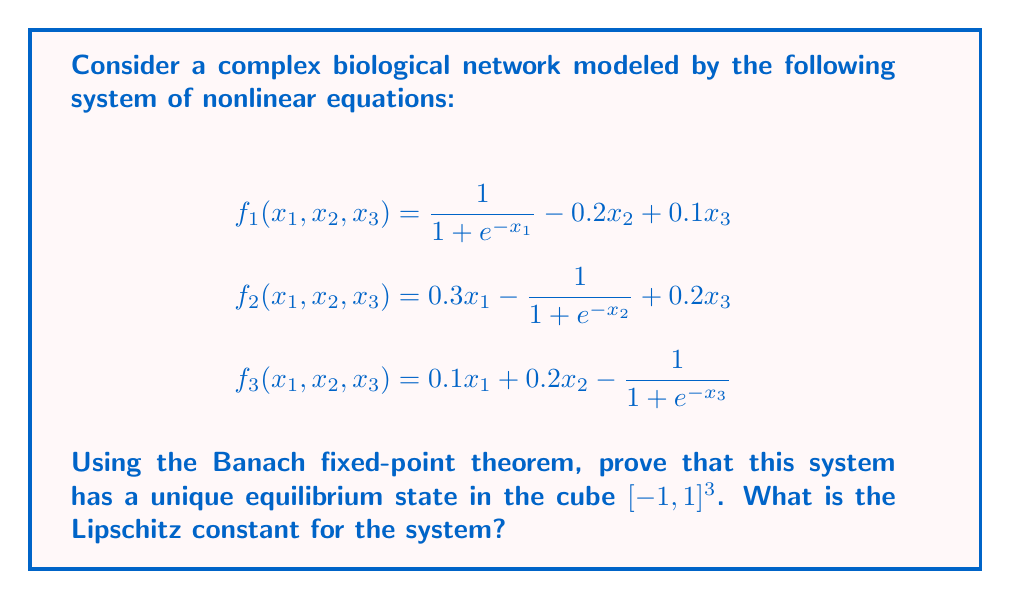Can you solve this math problem? To apply the Banach fixed-point theorem, we need to show that the function $F(x) = (f_1(x), f_2(x), f_3(x))$ is a contraction mapping on $[-1, 1]^3$.

Step 1: Show that $F$ maps $[-1, 1]^3$ to itself.
For each $f_i$, the sigmoid term $\frac{1}{1 + e^{-x_i}}$ is always in $[0, 1]$. The linear terms are bounded by $\pm 0.3$. Thus, $|f_i(x)| \leq 1$ for all $x \in [-1, 1]^3$.

Step 2: Compute the Jacobian matrix of $F$.
$$J = \begin{bmatrix}
\frac{e^{-x_1}}{(1 + e^{-x_1})^2} & -0.2 & 0.1 \\
0.3 & \frac{e^{-x_2}}{(1 + e^{-x_2})^2} & 0.2 \\
0.1 & 0.2 & \frac{e^{-x_3}}{(1 + e^{-x_3})^2}
\end{bmatrix}$$

Step 3: Find an upper bound for $\|J\|_\infty$.
The maximum value of $\frac{e^{-x}}{(1 + e^{-x})^2}$ is 0.25 (at $x = 0$).
$\|J\|_\infty = \max\{0.25 + 0.2 + 0.1, 0.3 + 0.25 + 0.2, 0.1 + 0.2 + 0.25\} = 0.75$

Step 4: Apply the mean value theorem.
For any $x, y \in [-1, 1]^3$, $\|F(x) - F(y)\|_\infty \leq 0.75\|x - y\|_\infty$

Therefore, $F$ is a contraction mapping with Lipschitz constant $L = 0.75 < 1$.

By the Banach fixed-point theorem, $F$ has a unique fixed point in $[-1, 1]^3$, which corresponds to the unique equilibrium state of the biological network.
Answer: $L = 0.75$ 